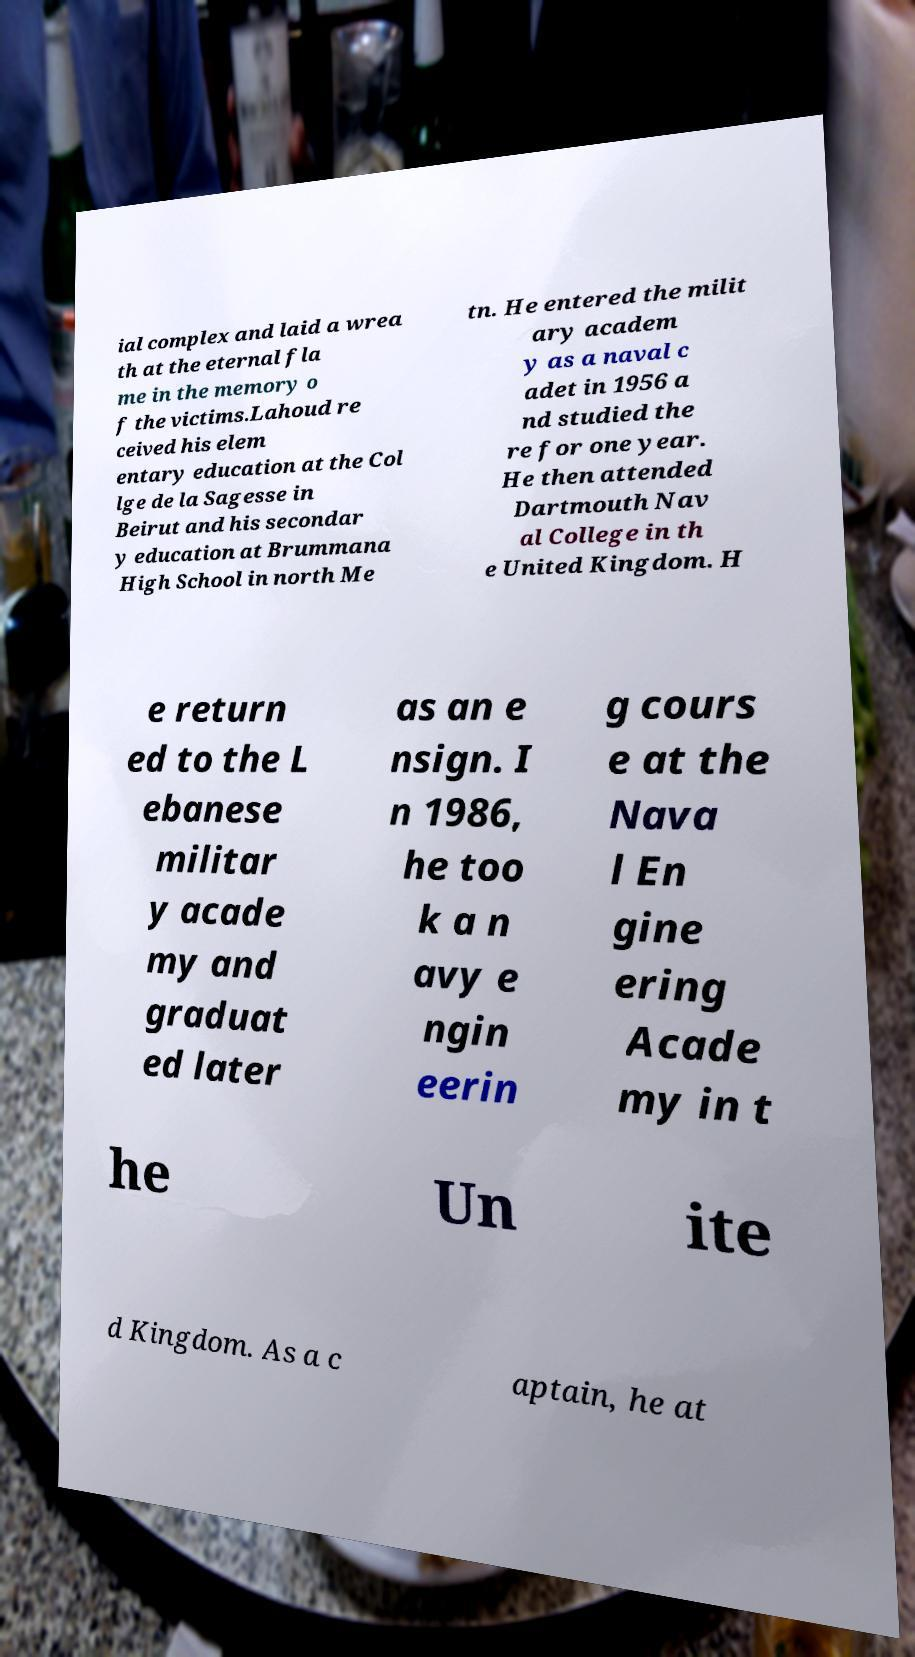Please identify and transcribe the text found in this image. ial complex and laid a wrea th at the eternal fla me in the memory o f the victims.Lahoud re ceived his elem entary education at the Col lge de la Sagesse in Beirut and his secondar y education at Brummana High School in north Me tn. He entered the milit ary academ y as a naval c adet in 1956 a nd studied the re for one year. He then attended Dartmouth Nav al College in th e United Kingdom. H e return ed to the L ebanese militar y acade my and graduat ed later as an e nsign. I n 1986, he too k a n avy e ngin eerin g cours e at the Nava l En gine ering Acade my in t he Un ite d Kingdom. As a c aptain, he at 